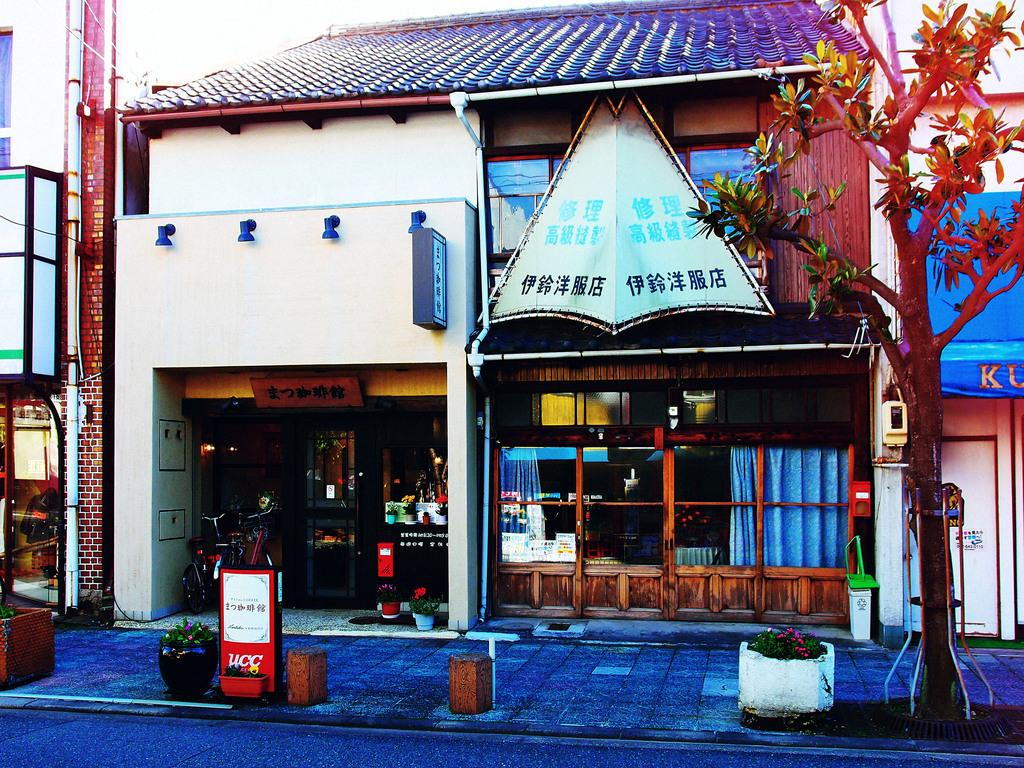What types of vegetation are present at the bottom of the image? There are plants and trees at the bottom of the image. What else can be seen at the bottom of the image? There are poles at the bottom of the image. What structures are located in the middle of the image? There are buildings in the middle of the image. What objects are inside the buildings? There are bicycles inside the buildings. How many mice can be seen climbing on the poles in the image? There are no mice present in the image; it only features plants, trees, poles, buildings, and bicycles. What type of noise can be heard coming from the spiders in the image? There are no spiders present in the image, so it is not possible to determine what noise they might make. 